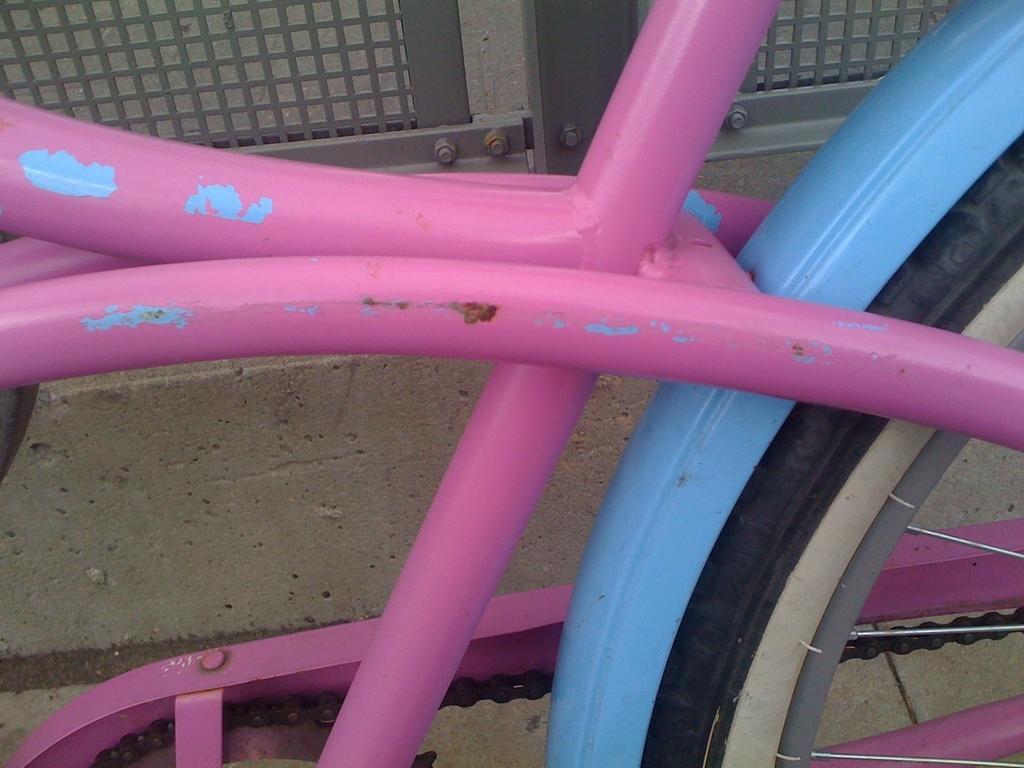Could you give a brief overview of what you see in this image? In this image there is a bicycle, there is ground, there is a metal fence towards the top of the image. 